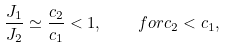<formula> <loc_0><loc_0><loc_500><loc_500>\frac { J _ { 1 } } { J _ { 2 } } \simeq \frac { c _ { 2 } } { c _ { 1 } } < 1 , \quad f o r c _ { 2 } < c _ { 1 } ,</formula> 